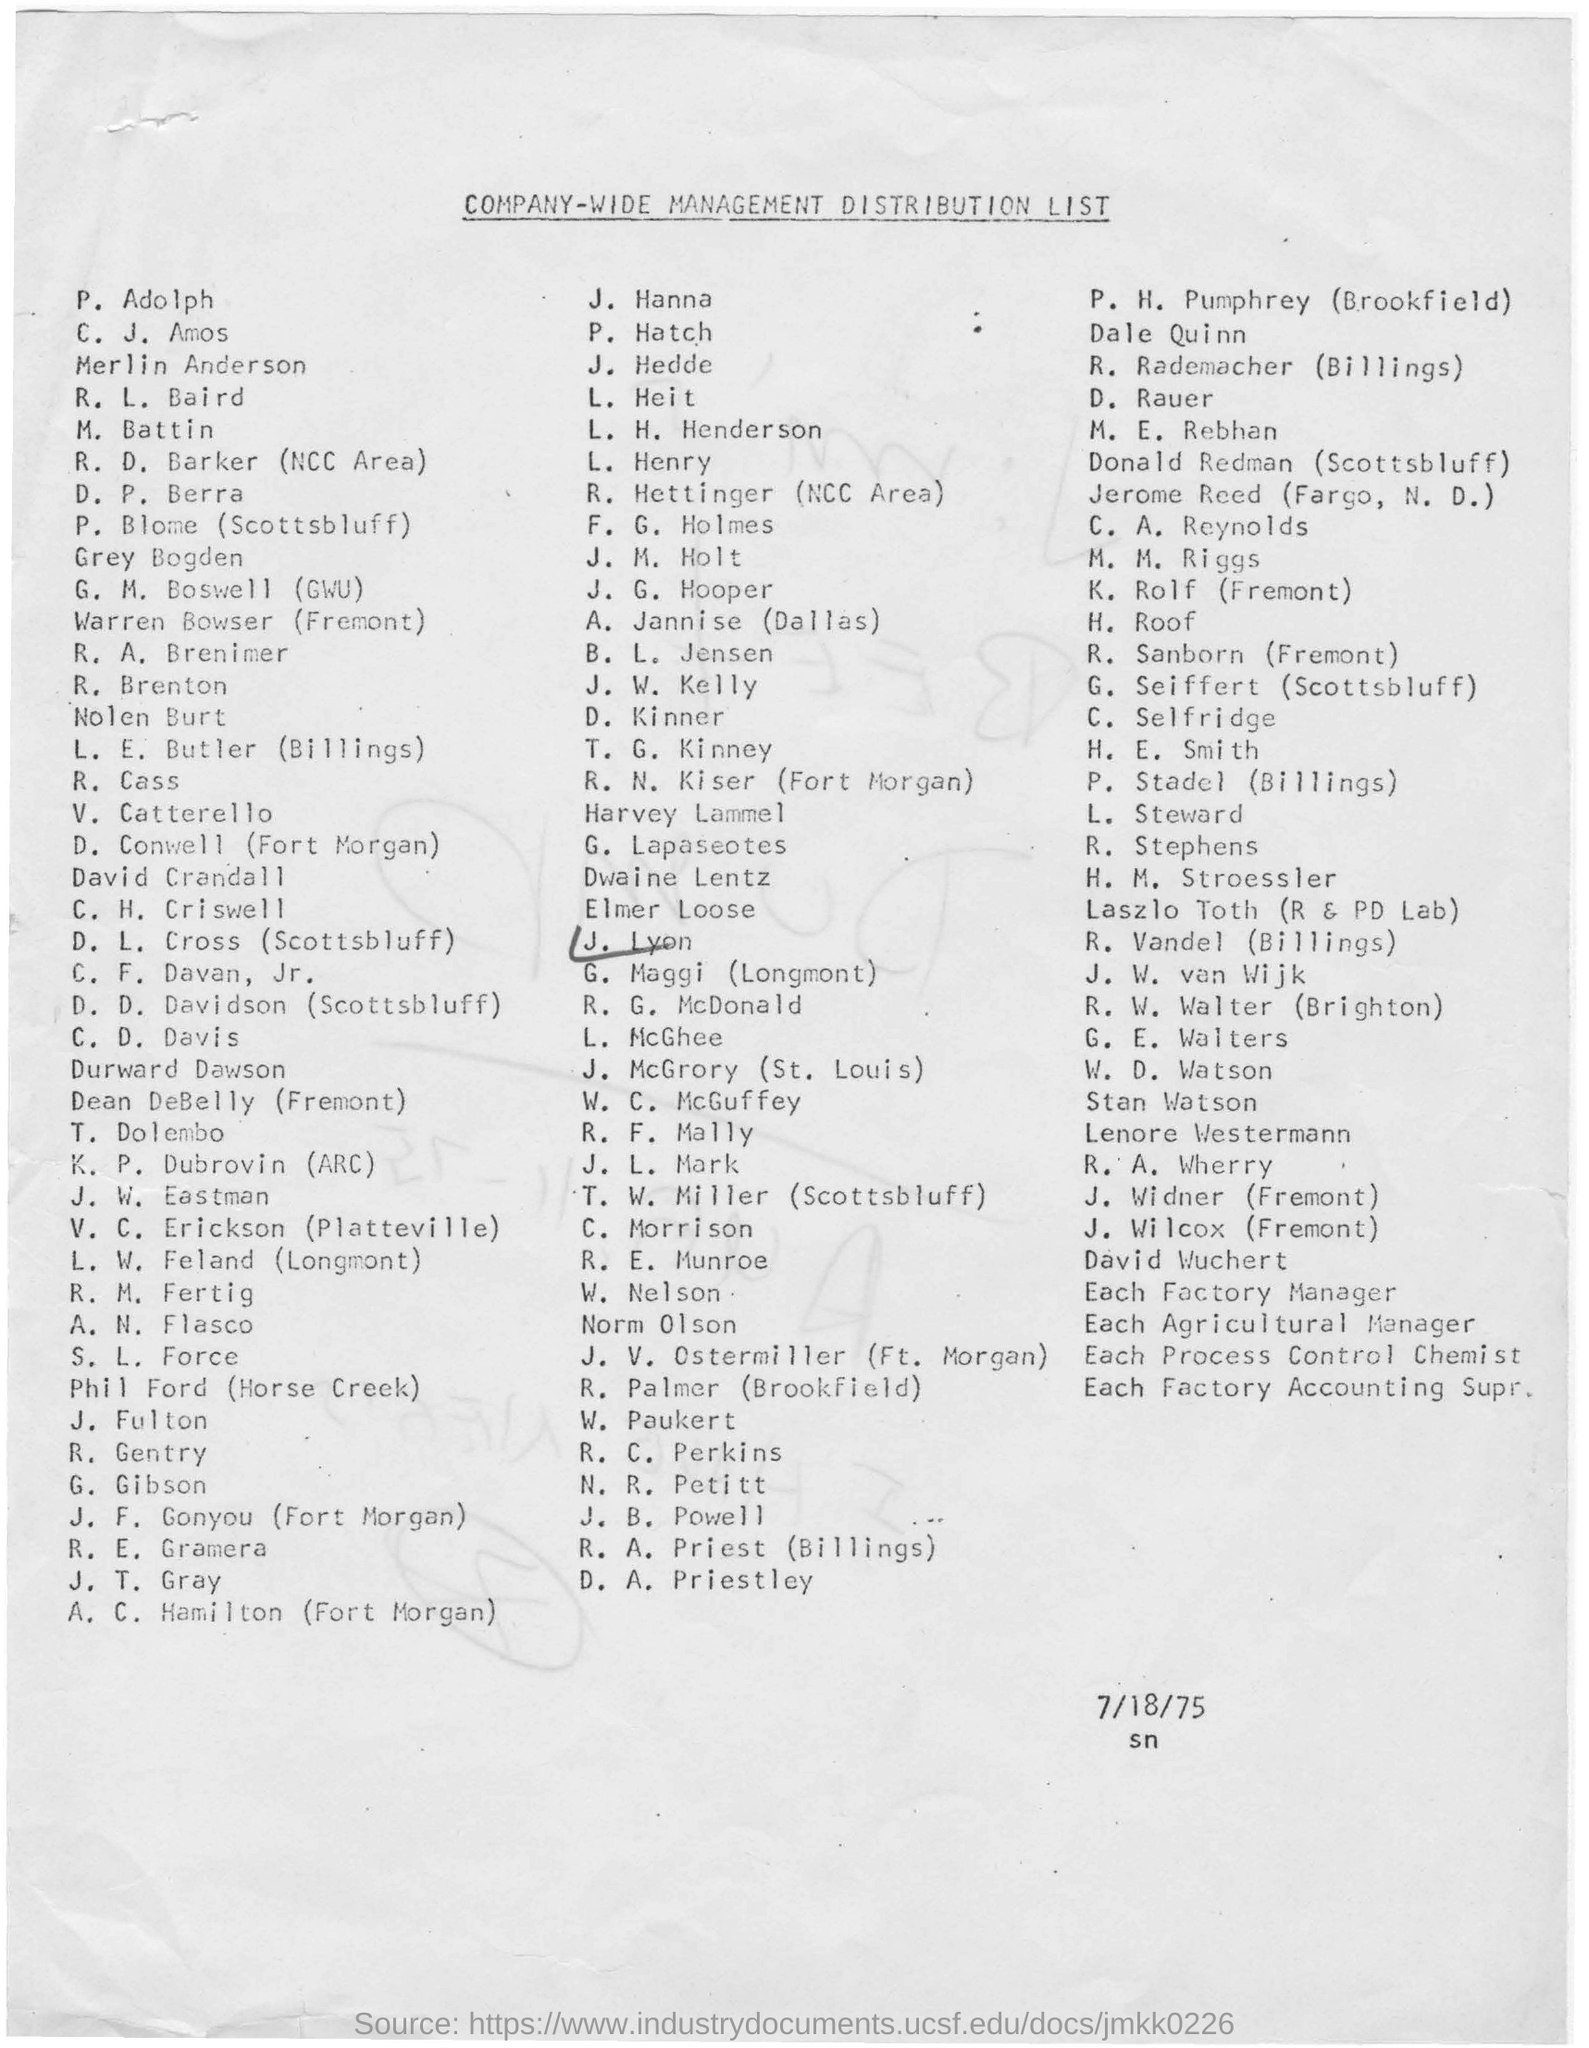Mention a couple of crucial points in this snapshot. The date mentioned below the document is 7/18/75. The name "J. Lyon" is circled using a pen in the list. The document is about company-wide management, distribution, and related matters. 